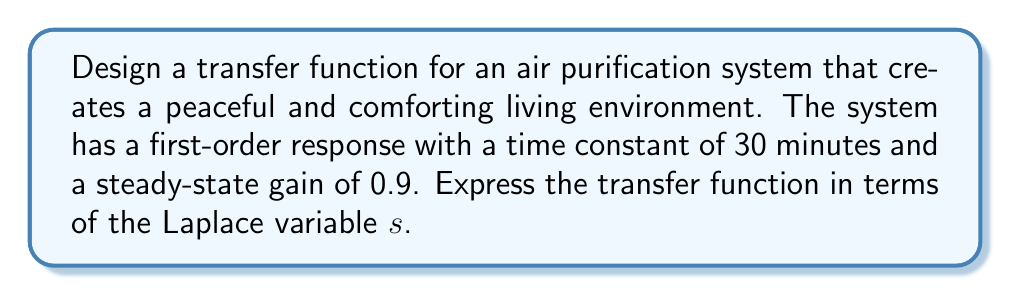Show me your answer to this math problem. To model the transfer function of an air purification system, we'll use a first-order system approach, which is suitable for many real-world processes, including air quality improvement.

1. The general form of a first-order transfer function is:

   $$G(s) = \frac{K}{\tau s + 1}$$

   where $K$ is the steady-state gain and $\tau$ is the time constant.

2. We are given:
   - Time constant $\tau = 30$ minutes
   - Steady-state gain $K = 0.9$

3. To express the time constant in terms of the Laplace variable $s$, we need to consider that $s$ is in units of $\text{seconds}^{-1}$. Therefore, we must convert 30 minutes to seconds:

   $30 \text{ minutes} = 30 \times 60 = 1800 \text{ seconds}$

4. Now we can substitute the values into the transfer function:

   $$G(s) = \frac{0.9}{1800s + 1}$$

5. To simplify, we can factor out 1800 from the denominator:

   $$G(s) = \frac{0.9}{1800(s + \frac{1}{1800})}$$

This transfer function models how the air purification system responds to input changes, creating a calm and peaceful environment by gradually improving air quality.
Answer: $$G(s) = \frac{0.9}{1800s + 1}$$ or $$G(s) = \frac{0.9}{1800(s + \frac{1}{1800})}$$ 